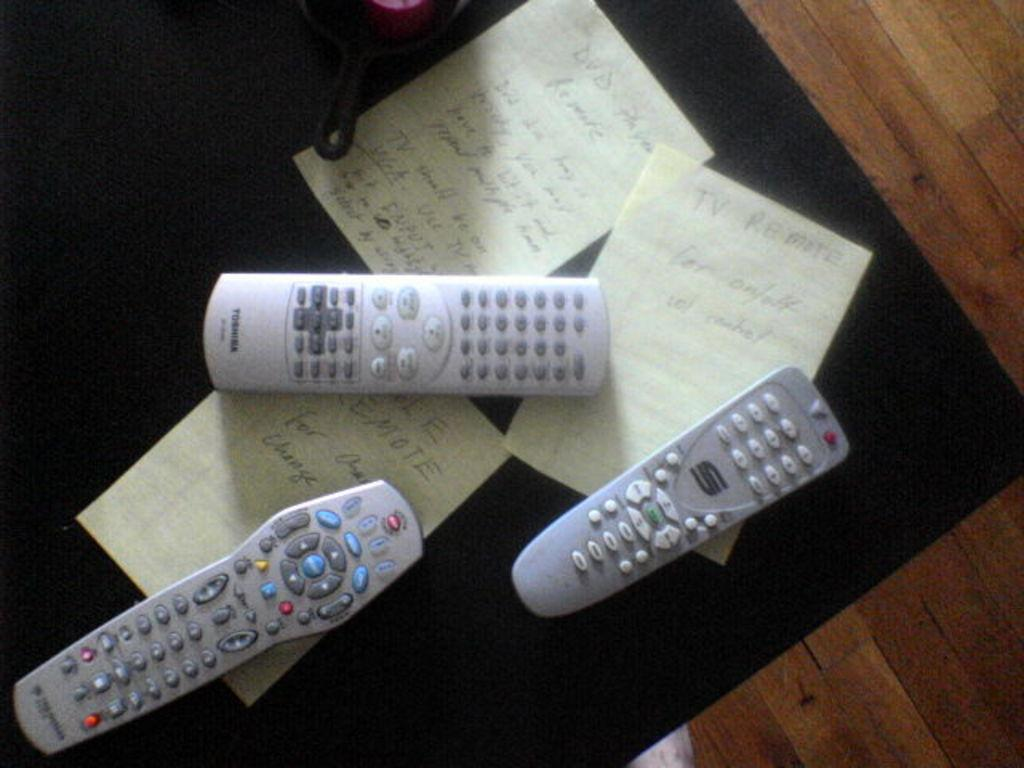<image>
Render a clear and concise summary of the photo. Three remotes are on a coffee table with notes that say TV Remote. 